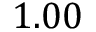<formula> <loc_0><loc_0><loc_500><loc_500>1 . 0 0</formula> 